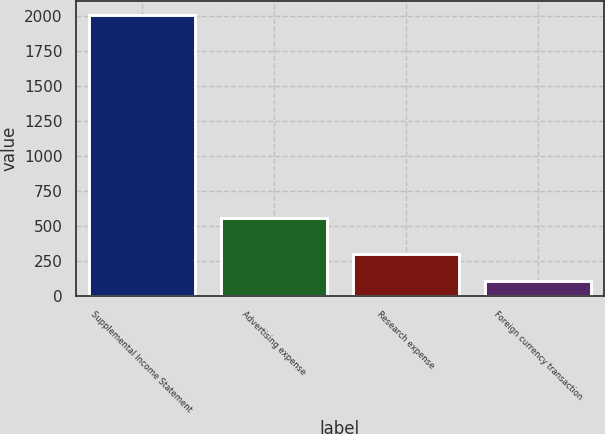Convert chart to OTSL. <chart><loc_0><loc_0><loc_500><loc_500><bar_chart><fcel>Supplemental Income Statement<fcel>Advertising expense<fcel>Research expense<fcel>Foreign currency transaction<nl><fcel>2009<fcel>559<fcel>301<fcel>110<nl></chart> 